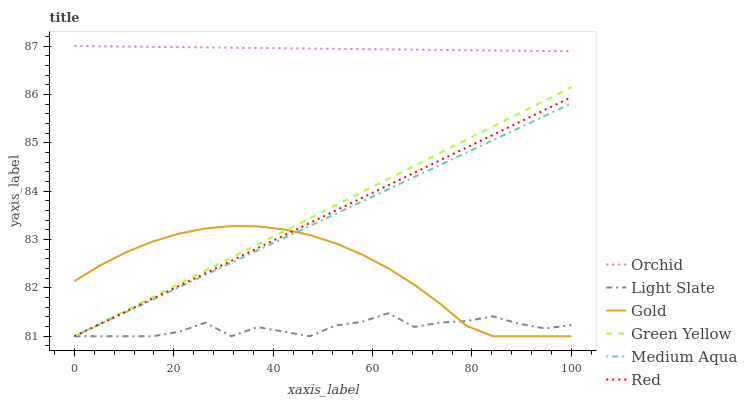Does Light Slate have the minimum area under the curve?
Answer yes or no. Yes. Does Orchid have the maximum area under the curve?
Answer yes or no. Yes. Does Medium Aqua have the minimum area under the curve?
Answer yes or no. No. Does Medium Aqua have the maximum area under the curve?
Answer yes or no. No. Is Orchid the smoothest?
Answer yes or no. Yes. Is Light Slate the roughest?
Answer yes or no. Yes. Is Medium Aqua the smoothest?
Answer yes or no. No. Is Medium Aqua the roughest?
Answer yes or no. No. Does Gold have the lowest value?
Answer yes or no. Yes. Does Orchid have the lowest value?
Answer yes or no. No. Does Orchid have the highest value?
Answer yes or no. Yes. Does Medium Aqua have the highest value?
Answer yes or no. No. Is Light Slate less than Orchid?
Answer yes or no. Yes. Is Orchid greater than Gold?
Answer yes or no. Yes. Does Red intersect Gold?
Answer yes or no. Yes. Is Red less than Gold?
Answer yes or no. No. Is Red greater than Gold?
Answer yes or no. No. Does Light Slate intersect Orchid?
Answer yes or no. No. 